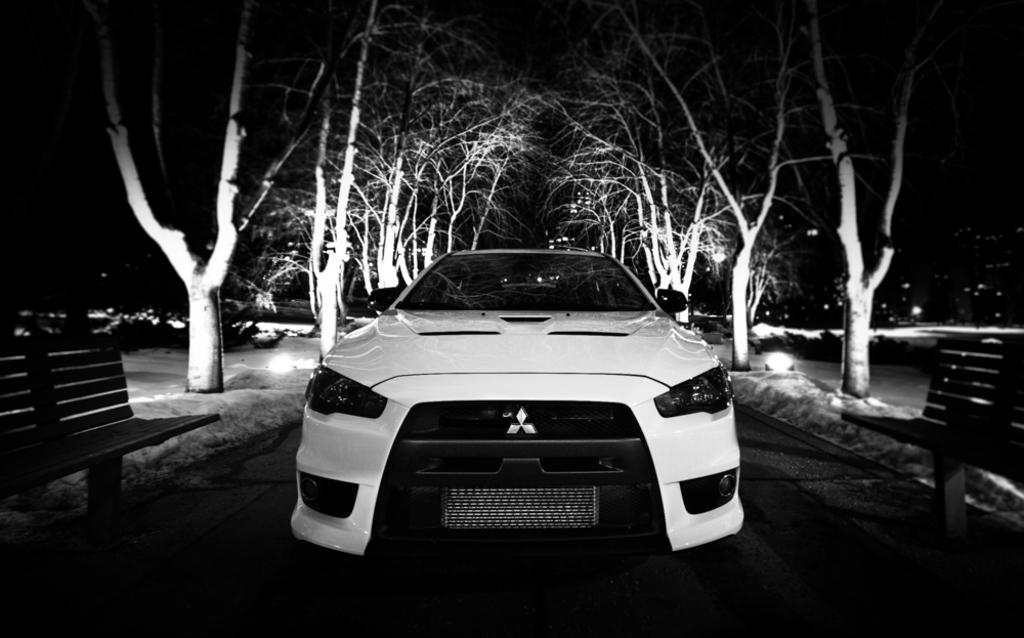What type of vegetation can be seen in the image? There are trees in the image. What type of seating is available in the image? There are benches in the image. What type of illumination is present in the image? There are lights in the image. What type of vehicle is visible in the image? There is a white color car in the image. How would you describe the overall lighting in the image? The image is slightly dark. What type of flowers are growing near the trees in the image? There are no flowers mentioned or visible in the image. What is the tendency of the car to move in the image? The car is stationary in the image and does not have a tendency to move. 